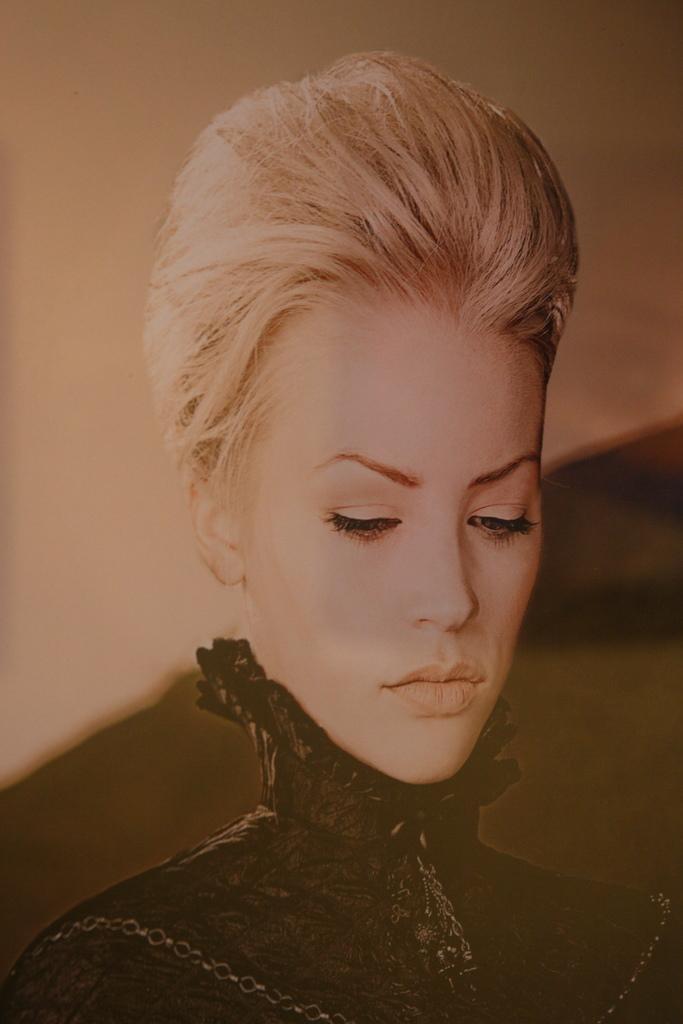Please provide a concise description of this image. This is an edited image. There is a person in the middle. She is a woman. She is wearing black dress. 